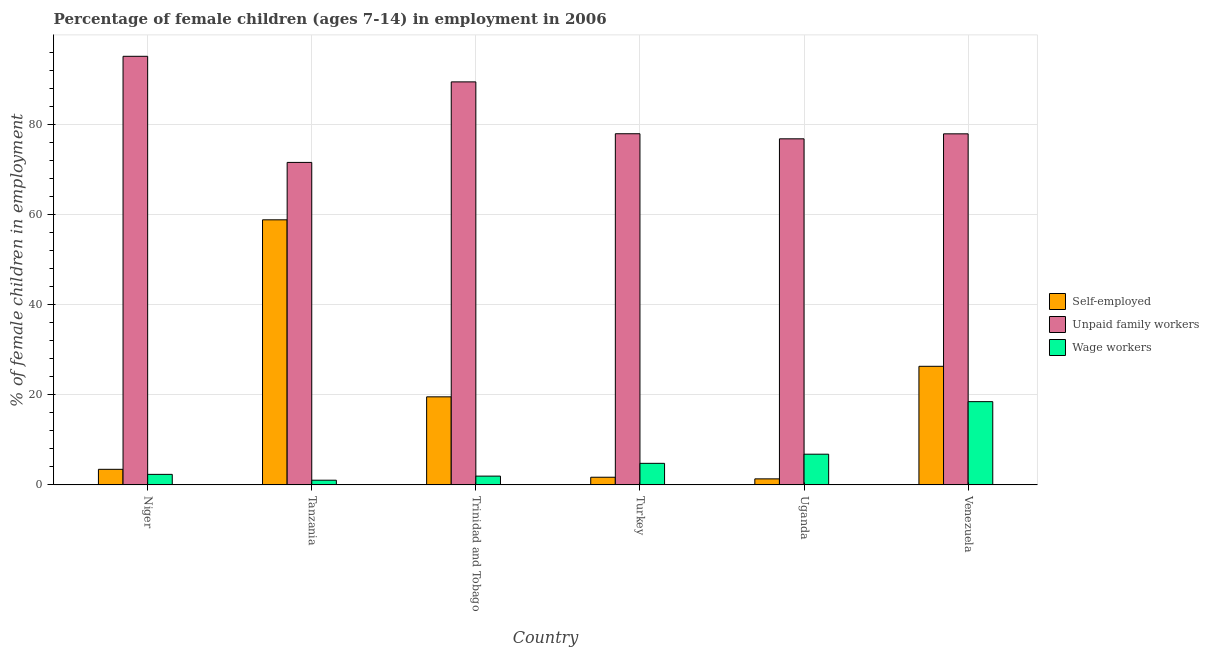How many different coloured bars are there?
Provide a short and direct response. 3. How many groups of bars are there?
Provide a succinct answer. 6. How many bars are there on the 3rd tick from the left?
Your answer should be very brief. 3. How many bars are there on the 1st tick from the right?
Provide a succinct answer. 3. What is the label of the 1st group of bars from the left?
Keep it short and to the point. Niger. What is the percentage of children employed as wage workers in Venezuela?
Provide a short and direct response. 18.49. Across all countries, what is the maximum percentage of self employed children?
Offer a very short reply. 58.88. Across all countries, what is the minimum percentage of self employed children?
Provide a short and direct response. 1.34. In which country was the percentage of self employed children maximum?
Provide a succinct answer. Tanzania. In which country was the percentage of self employed children minimum?
Give a very brief answer. Uganda. What is the total percentage of children employed as unpaid family workers in the graph?
Give a very brief answer. 489.2. What is the difference between the percentage of children employed as wage workers in Tanzania and that in Trinidad and Tobago?
Give a very brief answer. -0.91. What is the difference between the percentage of self employed children in Niger and the percentage of children employed as wage workers in Tanzania?
Keep it short and to the point. 2.42. What is the average percentage of children employed as unpaid family workers per country?
Provide a succinct answer. 81.53. What is the difference between the percentage of self employed children and percentage of children employed as wage workers in Venezuela?
Your answer should be compact. 7.85. In how many countries, is the percentage of children employed as unpaid family workers greater than 28 %?
Ensure brevity in your answer.  6. What is the ratio of the percentage of self employed children in Tanzania to that in Trinidad and Tobago?
Give a very brief answer. 3.01. What is the difference between the highest and the second highest percentage of children employed as unpaid family workers?
Offer a terse response. 5.68. What is the difference between the highest and the lowest percentage of self employed children?
Offer a terse response. 57.54. What does the 3rd bar from the left in Uganda represents?
Your answer should be very brief. Wage workers. What does the 1st bar from the right in Niger represents?
Offer a very short reply. Wage workers. Is it the case that in every country, the sum of the percentage of self employed children and percentage of children employed as unpaid family workers is greater than the percentage of children employed as wage workers?
Offer a terse response. Yes. How many bars are there?
Offer a very short reply. 18. Are all the bars in the graph horizontal?
Give a very brief answer. No. How many countries are there in the graph?
Your answer should be very brief. 6. What is the difference between two consecutive major ticks on the Y-axis?
Provide a succinct answer. 20. Are the values on the major ticks of Y-axis written in scientific E-notation?
Provide a short and direct response. No. Does the graph contain any zero values?
Give a very brief answer. No. Does the graph contain grids?
Provide a short and direct response. Yes. Where does the legend appear in the graph?
Your answer should be compact. Center right. How many legend labels are there?
Your response must be concise. 3. What is the title of the graph?
Your response must be concise. Percentage of female children (ages 7-14) in employment in 2006. What is the label or title of the Y-axis?
Provide a succinct answer. % of female children in employment. What is the % of female children in employment in Self-employed in Niger?
Make the answer very short. 3.46. What is the % of female children in employment in Unpaid family workers in Niger?
Your answer should be very brief. 95.2. What is the % of female children in employment of Wage workers in Niger?
Give a very brief answer. 2.34. What is the % of female children in employment of Self-employed in Tanzania?
Your response must be concise. 58.88. What is the % of female children in employment of Unpaid family workers in Tanzania?
Your response must be concise. 71.63. What is the % of female children in employment of Wage workers in Tanzania?
Your response must be concise. 1.04. What is the % of female children in employment in Self-employed in Trinidad and Tobago?
Your response must be concise. 19.56. What is the % of female children in employment in Unpaid family workers in Trinidad and Tobago?
Provide a short and direct response. 89.52. What is the % of female children in employment of Wage workers in Trinidad and Tobago?
Ensure brevity in your answer.  1.95. What is the % of female children in employment in Self-employed in Turkey?
Offer a very short reply. 1.7. What is the % of female children in employment of Wage workers in Turkey?
Provide a short and direct response. 4.79. What is the % of female children in employment of Self-employed in Uganda?
Make the answer very short. 1.34. What is the % of female children in employment in Unpaid family workers in Uganda?
Make the answer very short. 76.87. What is the % of female children in employment in Wage workers in Uganda?
Offer a terse response. 6.82. What is the % of female children in employment of Self-employed in Venezuela?
Give a very brief answer. 26.34. What is the % of female children in employment in Unpaid family workers in Venezuela?
Give a very brief answer. 77.98. What is the % of female children in employment in Wage workers in Venezuela?
Your answer should be very brief. 18.49. Across all countries, what is the maximum % of female children in employment of Self-employed?
Your answer should be very brief. 58.88. Across all countries, what is the maximum % of female children in employment in Unpaid family workers?
Offer a very short reply. 95.2. Across all countries, what is the maximum % of female children in employment of Wage workers?
Your response must be concise. 18.49. Across all countries, what is the minimum % of female children in employment in Self-employed?
Offer a very short reply. 1.34. Across all countries, what is the minimum % of female children in employment in Unpaid family workers?
Make the answer very short. 71.63. Across all countries, what is the minimum % of female children in employment of Wage workers?
Make the answer very short. 1.04. What is the total % of female children in employment in Self-employed in the graph?
Provide a short and direct response. 111.28. What is the total % of female children in employment in Unpaid family workers in the graph?
Keep it short and to the point. 489.2. What is the total % of female children in employment in Wage workers in the graph?
Your answer should be compact. 35.43. What is the difference between the % of female children in employment in Self-employed in Niger and that in Tanzania?
Offer a terse response. -55.42. What is the difference between the % of female children in employment of Unpaid family workers in Niger and that in Tanzania?
Keep it short and to the point. 23.57. What is the difference between the % of female children in employment in Wage workers in Niger and that in Tanzania?
Your answer should be compact. 1.3. What is the difference between the % of female children in employment of Self-employed in Niger and that in Trinidad and Tobago?
Keep it short and to the point. -16.1. What is the difference between the % of female children in employment in Unpaid family workers in Niger and that in Trinidad and Tobago?
Your response must be concise. 5.68. What is the difference between the % of female children in employment in Wage workers in Niger and that in Trinidad and Tobago?
Your answer should be very brief. 0.39. What is the difference between the % of female children in employment in Self-employed in Niger and that in Turkey?
Ensure brevity in your answer.  1.76. What is the difference between the % of female children in employment of Unpaid family workers in Niger and that in Turkey?
Your answer should be very brief. 17.2. What is the difference between the % of female children in employment of Wage workers in Niger and that in Turkey?
Provide a succinct answer. -2.45. What is the difference between the % of female children in employment of Self-employed in Niger and that in Uganda?
Give a very brief answer. 2.12. What is the difference between the % of female children in employment in Unpaid family workers in Niger and that in Uganda?
Offer a very short reply. 18.33. What is the difference between the % of female children in employment in Wage workers in Niger and that in Uganda?
Keep it short and to the point. -4.48. What is the difference between the % of female children in employment in Self-employed in Niger and that in Venezuela?
Make the answer very short. -22.88. What is the difference between the % of female children in employment in Unpaid family workers in Niger and that in Venezuela?
Offer a very short reply. 17.22. What is the difference between the % of female children in employment in Wage workers in Niger and that in Venezuela?
Offer a very short reply. -16.15. What is the difference between the % of female children in employment in Self-employed in Tanzania and that in Trinidad and Tobago?
Your answer should be compact. 39.32. What is the difference between the % of female children in employment of Unpaid family workers in Tanzania and that in Trinidad and Tobago?
Offer a very short reply. -17.89. What is the difference between the % of female children in employment in Wage workers in Tanzania and that in Trinidad and Tobago?
Your response must be concise. -0.91. What is the difference between the % of female children in employment in Self-employed in Tanzania and that in Turkey?
Provide a succinct answer. 57.18. What is the difference between the % of female children in employment in Unpaid family workers in Tanzania and that in Turkey?
Make the answer very short. -6.37. What is the difference between the % of female children in employment in Wage workers in Tanzania and that in Turkey?
Your answer should be compact. -3.75. What is the difference between the % of female children in employment of Self-employed in Tanzania and that in Uganda?
Offer a terse response. 57.54. What is the difference between the % of female children in employment in Unpaid family workers in Tanzania and that in Uganda?
Offer a very short reply. -5.24. What is the difference between the % of female children in employment of Wage workers in Tanzania and that in Uganda?
Ensure brevity in your answer.  -5.78. What is the difference between the % of female children in employment of Self-employed in Tanzania and that in Venezuela?
Provide a short and direct response. 32.54. What is the difference between the % of female children in employment in Unpaid family workers in Tanzania and that in Venezuela?
Give a very brief answer. -6.35. What is the difference between the % of female children in employment in Wage workers in Tanzania and that in Venezuela?
Keep it short and to the point. -17.45. What is the difference between the % of female children in employment of Self-employed in Trinidad and Tobago and that in Turkey?
Your answer should be very brief. 17.86. What is the difference between the % of female children in employment in Unpaid family workers in Trinidad and Tobago and that in Turkey?
Provide a short and direct response. 11.52. What is the difference between the % of female children in employment in Wage workers in Trinidad and Tobago and that in Turkey?
Your answer should be compact. -2.84. What is the difference between the % of female children in employment in Self-employed in Trinidad and Tobago and that in Uganda?
Your response must be concise. 18.22. What is the difference between the % of female children in employment in Unpaid family workers in Trinidad and Tobago and that in Uganda?
Offer a very short reply. 12.65. What is the difference between the % of female children in employment in Wage workers in Trinidad and Tobago and that in Uganda?
Provide a succinct answer. -4.87. What is the difference between the % of female children in employment in Self-employed in Trinidad and Tobago and that in Venezuela?
Provide a short and direct response. -6.78. What is the difference between the % of female children in employment of Unpaid family workers in Trinidad and Tobago and that in Venezuela?
Provide a succinct answer. 11.54. What is the difference between the % of female children in employment in Wage workers in Trinidad and Tobago and that in Venezuela?
Offer a very short reply. -16.54. What is the difference between the % of female children in employment in Self-employed in Turkey and that in Uganda?
Your answer should be compact. 0.36. What is the difference between the % of female children in employment of Unpaid family workers in Turkey and that in Uganda?
Offer a very short reply. 1.13. What is the difference between the % of female children in employment of Wage workers in Turkey and that in Uganda?
Keep it short and to the point. -2.03. What is the difference between the % of female children in employment in Self-employed in Turkey and that in Venezuela?
Provide a succinct answer. -24.64. What is the difference between the % of female children in employment of Wage workers in Turkey and that in Venezuela?
Make the answer very short. -13.7. What is the difference between the % of female children in employment of Unpaid family workers in Uganda and that in Venezuela?
Your response must be concise. -1.11. What is the difference between the % of female children in employment in Wage workers in Uganda and that in Venezuela?
Keep it short and to the point. -11.67. What is the difference between the % of female children in employment of Self-employed in Niger and the % of female children in employment of Unpaid family workers in Tanzania?
Provide a short and direct response. -68.17. What is the difference between the % of female children in employment of Self-employed in Niger and the % of female children in employment of Wage workers in Tanzania?
Make the answer very short. 2.42. What is the difference between the % of female children in employment in Unpaid family workers in Niger and the % of female children in employment in Wage workers in Tanzania?
Your response must be concise. 94.16. What is the difference between the % of female children in employment of Self-employed in Niger and the % of female children in employment of Unpaid family workers in Trinidad and Tobago?
Your response must be concise. -86.06. What is the difference between the % of female children in employment of Self-employed in Niger and the % of female children in employment of Wage workers in Trinidad and Tobago?
Offer a very short reply. 1.51. What is the difference between the % of female children in employment in Unpaid family workers in Niger and the % of female children in employment in Wage workers in Trinidad and Tobago?
Your answer should be very brief. 93.25. What is the difference between the % of female children in employment of Self-employed in Niger and the % of female children in employment of Unpaid family workers in Turkey?
Give a very brief answer. -74.54. What is the difference between the % of female children in employment of Self-employed in Niger and the % of female children in employment of Wage workers in Turkey?
Provide a succinct answer. -1.33. What is the difference between the % of female children in employment of Unpaid family workers in Niger and the % of female children in employment of Wage workers in Turkey?
Offer a very short reply. 90.41. What is the difference between the % of female children in employment of Self-employed in Niger and the % of female children in employment of Unpaid family workers in Uganda?
Provide a short and direct response. -73.41. What is the difference between the % of female children in employment in Self-employed in Niger and the % of female children in employment in Wage workers in Uganda?
Ensure brevity in your answer.  -3.36. What is the difference between the % of female children in employment of Unpaid family workers in Niger and the % of female children in employment of Wage workers in Uganda?
Provide a succinct answer. 88.38. What is the difference between the % of female children in employment of Self-employed in Niger and the % of female children in employment of Unpaid family workers in Venezuela?
Keep it short and to the point. -74.52. What is the difference between the % of female children in employment of Self-employed in Niger and the % of female children in employment of Wage workers in Venezuela?
Your answer should be compact. -15.03. What is the difference between the % of female children in employment in Unpaid family workers in Niger and the % of female children in employment in Wage workers in Venezuela?
Offer a very short reply. 76.71. What is the difference between the % of female children in employment of Self-employed in Tanzania and the % of female children in employment of Unpaid family workers in Trinidad and Tobago?
Keep it short and to the point. -30.64. What is the difference between the % of female children in employment of Self-employed in Tanzania and the % of female children in employment of Wage workers in Trinidad and Tobago?
Ensure brevity in your answer.  56.93. What is the difference between the % of female children in employment of Unpaid family workers in Tanzania and the % of female children in employment of Wage workers in Trinidad and Tobago?
Give a very brief answer. 69.68. What is the difference between the % of female children in employment in Self-employed in Tanzania and the % of female children in employment in Unpaid family workers in Turkey?
Offer a terse response. -19.12. What is the difference between the % of female children in employment in Self-employed in Tanzania and the % of female children in employment in Wage workers in Turkey?
Your response must be concise. 54.09. What is the difference between the % of female children in employment of Unpaid family workers in Tanzania and the % of female children in employment of Wage workers in Turkey?
Offer a terse response. 66.84. What is the difference between the % of female children in employment of Self-employed in Tanzania and the % of female children in employment of Unpaid family workers in Uganda?
Your answer should be very brief. -17.99. What is the difference between the % of female children in employment of Self-employed in Tanzania and the % of female children in employment of Wage workers in Uganda?
Your answer should be compact. 52.06. What is the difference between the % of female children in employment of Unpaid family workers in Tanzania and the % of female children in employment of Wage workers in Uganda?
Give a very brief answer. 64.81. What is the difference between the % of female children in employment of Self-employed in Tanzania and the % of female children in employment of Unpaid family workers in Venezuela?
Keep it short and to the point. -19.1. What is the difference between the % of female children in employment of Self-employed in Tanzania and the % of female children in employment of Wage workers in Venezuela?
Make the answer very short. 40.39. What is the difference between the % of female children in employment in Unpaid family workers in Tanzania and the % of female children in employment in Wage workers in Venezuela?
Give a very brief answer. 53.14. What is the difference between the % of female children in employment of Self-employed in Trinidad and Tobago and the % of female children in employment of Unpaid family workers in Turkey?
Your response must be concise. -58.44. What is the difference between the % of female children in employment of Self-employed in Trinidad and Tobago and the % of female children in employment of Wage workers in Turkey?
Offer a terse response. 14.77. What is the difference between the % of female children in employment in Unpaid family workers in Trinidad and Tobago and the % of female children in employment in Wage workers in Turkey?
Your response must be concise. 84.73. What is the difference between the % of female children in employment of Self-employed in Trinidad and Tobago and the % of female children in employment of Unpaid family workers in Uganda?
Offer a very short reply. -57.31. What is the difference between the % of female children in employment of Self-employed in Trinidad and Tobago and the % of female children in employment of Wage workers in Uganda?
Your answer should be very brief. 12.74. What is the difference between the % of female children in employment in Unpaid family workers in Trinidad and Tobago and the % of female children in employment in Wage workers in Uganda?
Offer a very short reply. 82.7. What is the difference between the % of female children in employment of Self-employed in Trinidad and Tobago and the % of female children in employment of Unpaid family workers in Venezuela?
Your answer should be very brief. -58.42. What is the difference between the % of female children in employment in Self-employed in Trinidad and Tobago and the % of female children in employment in Wage workers in Venezuela?
Offer a very short reply. 1.07. What is the difference between the % of female children in employment of Unpaid family workers in Trinidad and Tobago and the % of female children in employment of Wage workers in Venezuela?
Provide a short and direct response. 71.03. What is the difference between the % of female children in employment of Self-employed in Turkey and the % of female children in employment of Unpaid family workers in Uganda?
Your answer should be very brief. -75.17. What is the difference between the % of female children in employment of Self-employed in Turkey and the % of female children in employment of Wage workers in Uganda?
Your answer should be compact. -5.12. What is the difference between the % of female children in employment of Unpaid family workers in Turkey and the % of female children in employment of Wage workers in Uganda?
Give a very brief answer. 71.18. What is the difference between the % of female children in employment in Self-employed in Turkey and the % of female children in employment in Unpaid family workers in Venezuela?
Offer a terse response. -76.28. What is the difference between the % of female children in employment of Self-employed in Turkey and the % of female children in employment of Wage workers in Venezuela?
Give a very brief answer. -16.79. What is the difference between the % of female children in employment in Unpaid family workers in Turkey and the % of female children in employment in Wage workers in Venezuela?
Give a very brief answer. 59.51. What is the difference between the % of female children in employment in Self-employed in Uganda and the % of female children in employment in Unpaid family workers in Venezuela?
Offer a very short reply. -76.64. What is the difference between the % of female children in employment of Self-employed in Uganda and the % of female children in employment of Wage workers in Venezuela?
Provide a succinct answer. -17.15. What is the difference between the % of female children in employment of Unpaid family workers in Uganda and the % of female children in employment of Wage workers in Venezuela?
Offer a terse response. 58.38. What is the average % of female children in employment in Self-employed per country?
Provide a succinct answer. 18.55. What is the average % of female children in employment in Unpaid family workers per country?
Your response must be concise. 81.53. What is the average % of female children in employment of Wage workers per country?
Ensure brevity in your answer.  5.91. What is the difference between the % of female children in employment of Self-employed and % of female children in employment of Unpaid family workers in Niger?
Offer a terse response. -91.74. What is the difference between the % of female children in employment in Self-employed and % of female children in employment in Wage workers in Niger?
Your response must be concise. 1.12. What is the difference between the % of female children in employment of Unpaid family workers and % of female children in employment of Wage workers in Niger?
Your answer should be very brief. 92.86. What is the difference between the % of female children in employment of Self-employed and % of female children in employment of Unpaid family workers in Tanzania?
Provide a succinct answer. -12.75. What is the difference between the % of female children in employment in Self-employed and % of female children in employment in Wage workers in Tanzania?
Your answer should be very brief. 57.84. What is the difference between the % of female children in employment of Unpaid family workers and % of female children in employment of Wage workers in Tanzania?
Offer a very short reply. 70.59. What is the difference between the % of female children in employment of Self-employed and % of female children in employment of Unpaid family workers in Trinidad and Tobago?
Make the answer very short. -69.96. What is the difference between the % of female children in employment of Self-employed and % of female children in employment of Wage workers in Trinidad and Tobago?
Make the answer very short. 17.61. What is the difference between the % of female children in employment of Unpaid family workers and % of female children in employment of Wage workers in Trinidad and Tobago?
Provide a short and direct response. 87.57. What is the difference between the % of female children in employment in Self-employed and % of female children in employment in Unpaid family workers in Turkey?
Ensure brevity in your answer.  -76.3. What is the difference between the % of female children in employment in Self-employed and % of female children in employment in Wage workers in Turkey?
Give a very brief answer. -3.09. What is the difference between the % of female children in employment in Unpaid family workers and % of female children in employment in Wage workers in Turkey?
Ensure brevity in your answer.  73.21. What is the difference between the % of female children in employment in Self-employed and % of female children in employment in Unpaid family workers in Uganda?
Your answer should be very brief. -75.53. What is the difference between the % of female children in employment of Self-employed and % of female children in employment of Wage workers in Uganda?
Your answer should be compact. -5.48. What is the difference between the % of female children in employment of Unpaid family workers and % of female children in employment of Wage workers in Uganda?
Keep it short and to the point. 70.05. What is the difference between the % of female children in employment in Self-employed and % of female children in employment in Unpaid family workers in Venezuela?
Keep it short and to the point. -51.64. What is the difference between the % of female children in employment of Self-employed and % of female children in employment of Wage workers in Venezuela?
Make the answer very short. 7.85. What is the difference between the % of female children in employment of Unpaid family workers and % of female children in employment of Wage workers in Venezuela?
Offer a very short reply. 59.49. What is the ratio of the % of female children in employment in Self-employed in Niger to that in Tanzania?
Offer a very short reply. 0.06. What is the ratio of the % of female children in employment of Unpaid family workers in Niger to that in Tanzania?
Your answer should be very brief. 1.33. What is the ratio of the % of female children in employment in Wage workers in Niger to that in Tanzania?
Your answer should be very brief. 2.25. What is the ratio of the % of female children in employment in Self-employed in Niger to that in Trinidad and Tobago?
Make the answer very short. 0.18. What is the ratio of the % of female children in employment of Unpaid family workers in Niger to that in Trinidad and Tobago?
Offer a terse response. 1.06. What is the ratio of the % of female children in employment of Wage workers in Niger to that in Trinidad and Tobago?
Make the answer very short. 1.2. What is the ratio of the % of female children in employment in Self-employed in Niger to that in Turkey?
Your response must be concise. 2.04. What is the ratio of the % of female children in employment in Unpaid family workers in Niger to that in Turkey?
Offer a very short reply. 1.22. What is the ratio of the % of female children in employment of Wage workers in Niger to that in Turkey?
Your answer should be very brief. 0.49. What is the ratio of the % of female children in employment of Self-employed in Niger to that in Uganda?
Keep it short and to the point. 2.58. What is the ratio of the % of female children in employment in Unpaid family workers in Niger to that in Uganda?
Provide a short and direct response. 1.24. What is the ratio of the % of female children in employment of Wage workers in Niger to that in Uganda?
Keep it short and to the point. 0.34. What is the ratio of the % of female children in employment of Self-employed in Niger to that in Venezuela?
Provide a short and direct response. 0.13. What is the ratio of the % of female children in employment of Unpaid family workers in Niger to that in Venezuela?
Provide a succinct answer. 1.22. What is the ratio of the % of female children in employment of Wage workers in Niger to that in Venezuela?
Your response must be concise. 0.13. What is the ratio of the % of female children in employment in Self-employed in Tanzania to that in Trinidad and Tobago?
Your answer should be very brief. 3.01. What is the ratio of the % of female children in employment of Unpaid family workers in Tanzania to that in Trinidad and Tobago?
Your response must be concise. 0.8. What is the ratio of the % of female children in employment of Wage workers in Tanzania to that in Trinidad and Tobago?
Provide a short and direct response. 0.53. What is the ratio of the % of female children in employment of Self-employed in Tanzania to that in Turkey?
Ensure brevity in your answer.  34.64. What is the ratio of the % of female children in employment of Unpaid family workers in Tanzania to that in Turkey?
Provide a succinct answer. 0.92. What is the ratio of the % of female children in employment in Wage workers in Tanzania to that in Turkey?
Make the answer very short. 0.22. What is the ratio of the % of female children in employment in Self-employed in Tanzania to that in Uganda?
Offer a very short reply. 43.94. What is the ratio of the % of female children in employment of Unpaid family workers in Tanzania to that in Uganda?
Give a very brief answer. 0.93. What is the ratio of the % of female children in employment in Wage workers in Tanzania to that in Uganda?
Provide a short and direct response. 0.15. What is the ratio of the % of female children in employment of Self-employed in Tanzania to that in Venezuela?
Make the answer very short. 2.24. What is the ratio of the % of female children in employment in Unpaid family workers in Tanzania to that in Venezuela?
Give a very brief answer. 0.92. What is the ratio of the % of female children in employment in Wage workers in Tanzania to that in Venezuela?
Make the answer very short. 0.06. What is the ratio of the % of female children in employment of Self-employed in Trinidad and Tobago to that in Turkey?
Ensure brevity in your answer.  11.51. What is the ratio of the % of female children in employment in Unpaid family workers in Trinidad and Tobago to that in Turkey?
Offer a terse response. 1.15. What is the ratio of the % of female children in employment in Wage workers in Trinidad and Tobago to that in Turkey?
Provide a short and direct response. 0.41. What is the ratio of the % of female children in employment in Self-employed in Trinidad and Tobago to that in Uganda?
Your answer should be very brief. 14.6. What is the ratio of the % of female children in employment of Unpaid family workers in Trinidad and Tobago to that in Uganda?
Offer a very short reply. 1.16. What is the ratio of the % of female children in employment in Wage workers in Trinidad and Tobago to that in Uganda?
Keep it short and to the point. 0.29. What is the ratio of the % of female children in employment of Self-employed in Trinidad and Tobago to that in Venezuela?
Offer a very short reply. 0.74. What is the ratio of the % of female children in employment of Unpaid family workers in Trinidad and Tobago to that in Venezuela?
Your answer should be very brief. 1.15. What is the ratio of the % of female children in employment in Wage workers in Trinidad and Tobago to that in Venezuela?
Your answer should be very brief. 0.11. What is the ratio of the % of female children in employment of Self-employed in Turkey to that in Uganda?
Make the answer very short. 1.27. What is the ratio of the % of female children in employment of Unpaid family workers in Turkey to that in Uganda?
Provide a short and direct response. 1.01. What is the ratio of the % of female children in employment of Wage workers in Turkey to that in Uganda?
Provide a short and direct response. 0.7. What is the ratio of the % of female children in employment in Self-employed in Turkey to that in Venezuela?
Make the answer very short. 0.06. What is the ratio of the % of female children in employment in Unpaid family workers in Turkey to that in Venezuela?
Ensure brevity in your answer.  1. What is the ratio of the % of female children in employment of Wage workers in Turkey to that in Venezuela?
Your answer should be very brief. 0.26. What is the ratio of the % of female children in employment in Self-employed in Uganda to that in Venezuela?
Offer a terse response. 0.05. What is the ratio of the % of female children in employment of Unpaid family workers in Uganda to that in Venezuela?
Your answer should be compact. 0.99. What is the ratio of the % of female children in employment in Wage workers in Uganda to that in Venezuela?
Your answer should be compact. 0.37. What is the difference between the highest and the second highest % of female children in employment of Self-employed?
Give a very brief answer. 32.54. What is the difference between the highest and the second highest % of female children in employment in Unpaid family workers?
Give a very brief answer. 5.68. What is the difference between the highest and the second highest % of female children in employment in Wage workers?
Make the answer very short. 11.67. What is the difference between the highest and the lowest % of female children in employment of Self-employed?
Your answer should be compact. 57.54. What is the difference between the highest and the lowest % of female children in employment of Unpaid family workers?
Your answer should be very brief. 23.57. What is the difference between the highest and the lowest % of female children in employment of Wage workers?
Your answer should be very brief. 17.45. 